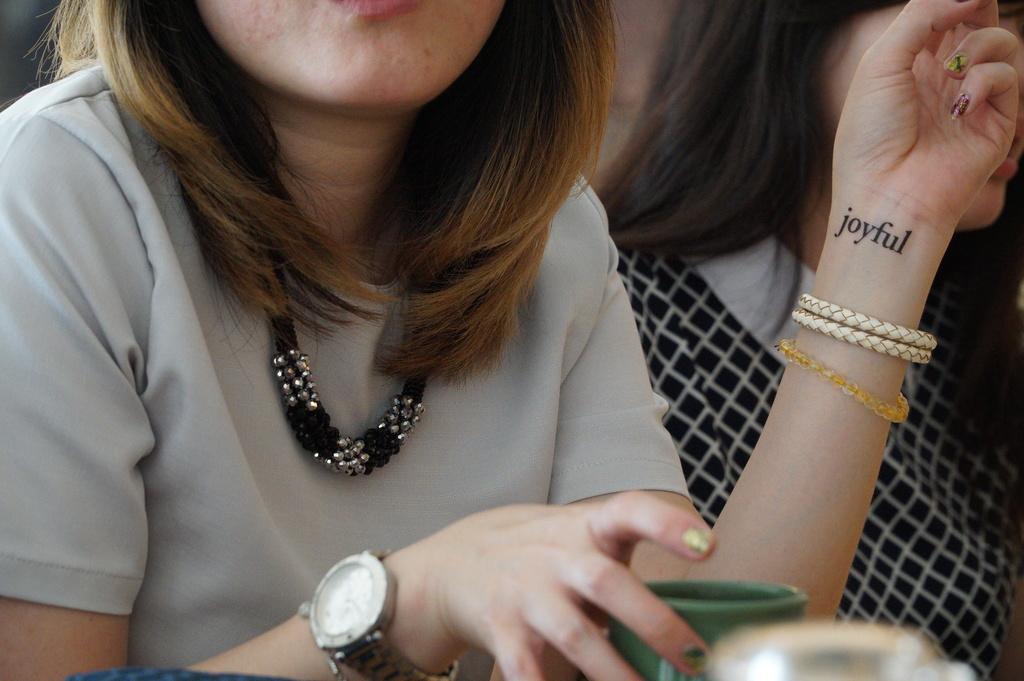What does the woman's tattoo say?
Your answer should be very brief. Joyful. 